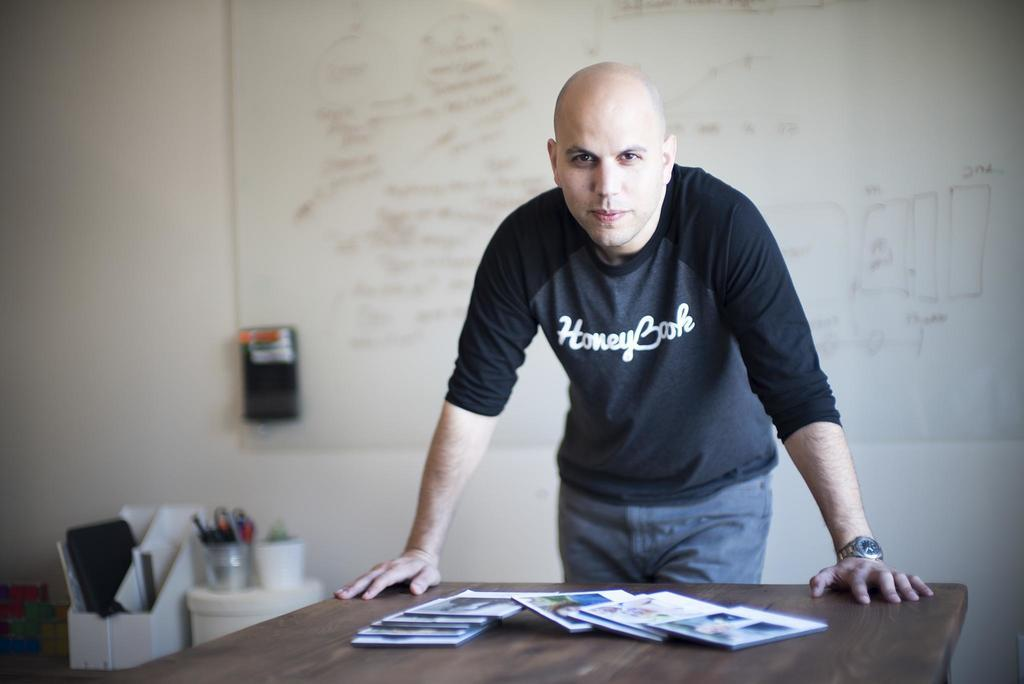What is the main subject of the image? There is a person standing in the image. What is the person wearing? The person is wearing black and ash pants. What can be seen on the table in the image? There are books on a table in the image. What is visible in the background of the image? There are objects visible in the background, and a board is attached to a white wall. How many boats can be seen sailing in the background of the image? There are no boats visible in the background of the image. What type of bead is the person wearing around their neck in the image? There is no bead visible around the person's neck in the image. 